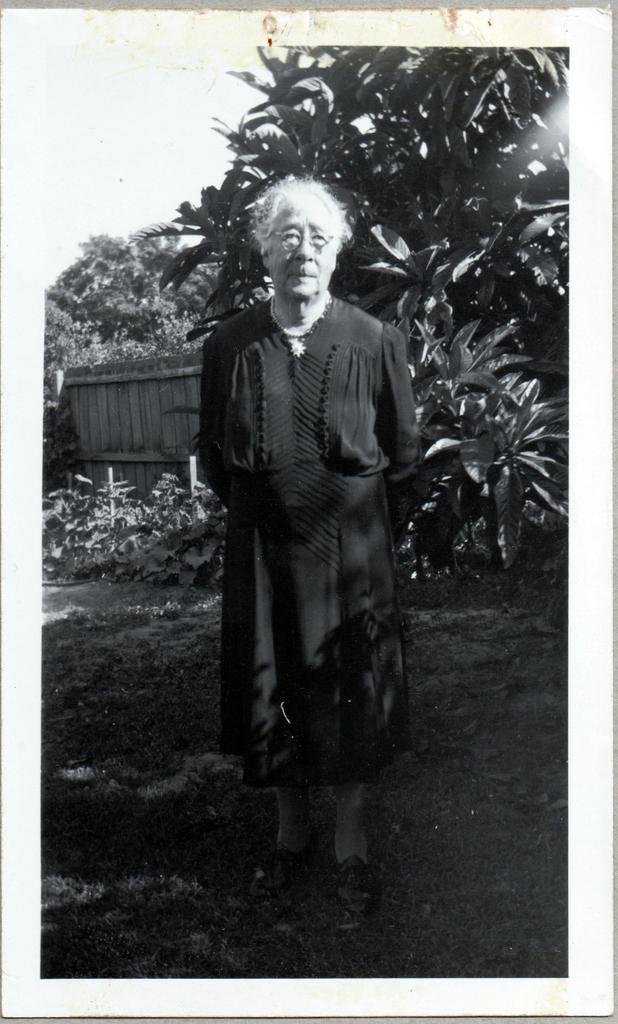Could you give a brief overview of what you see in this image? In this image I can see a man is standing. I can also see grass, wooden wall, plants and few trees. I can also see this image is black and white in colour. 